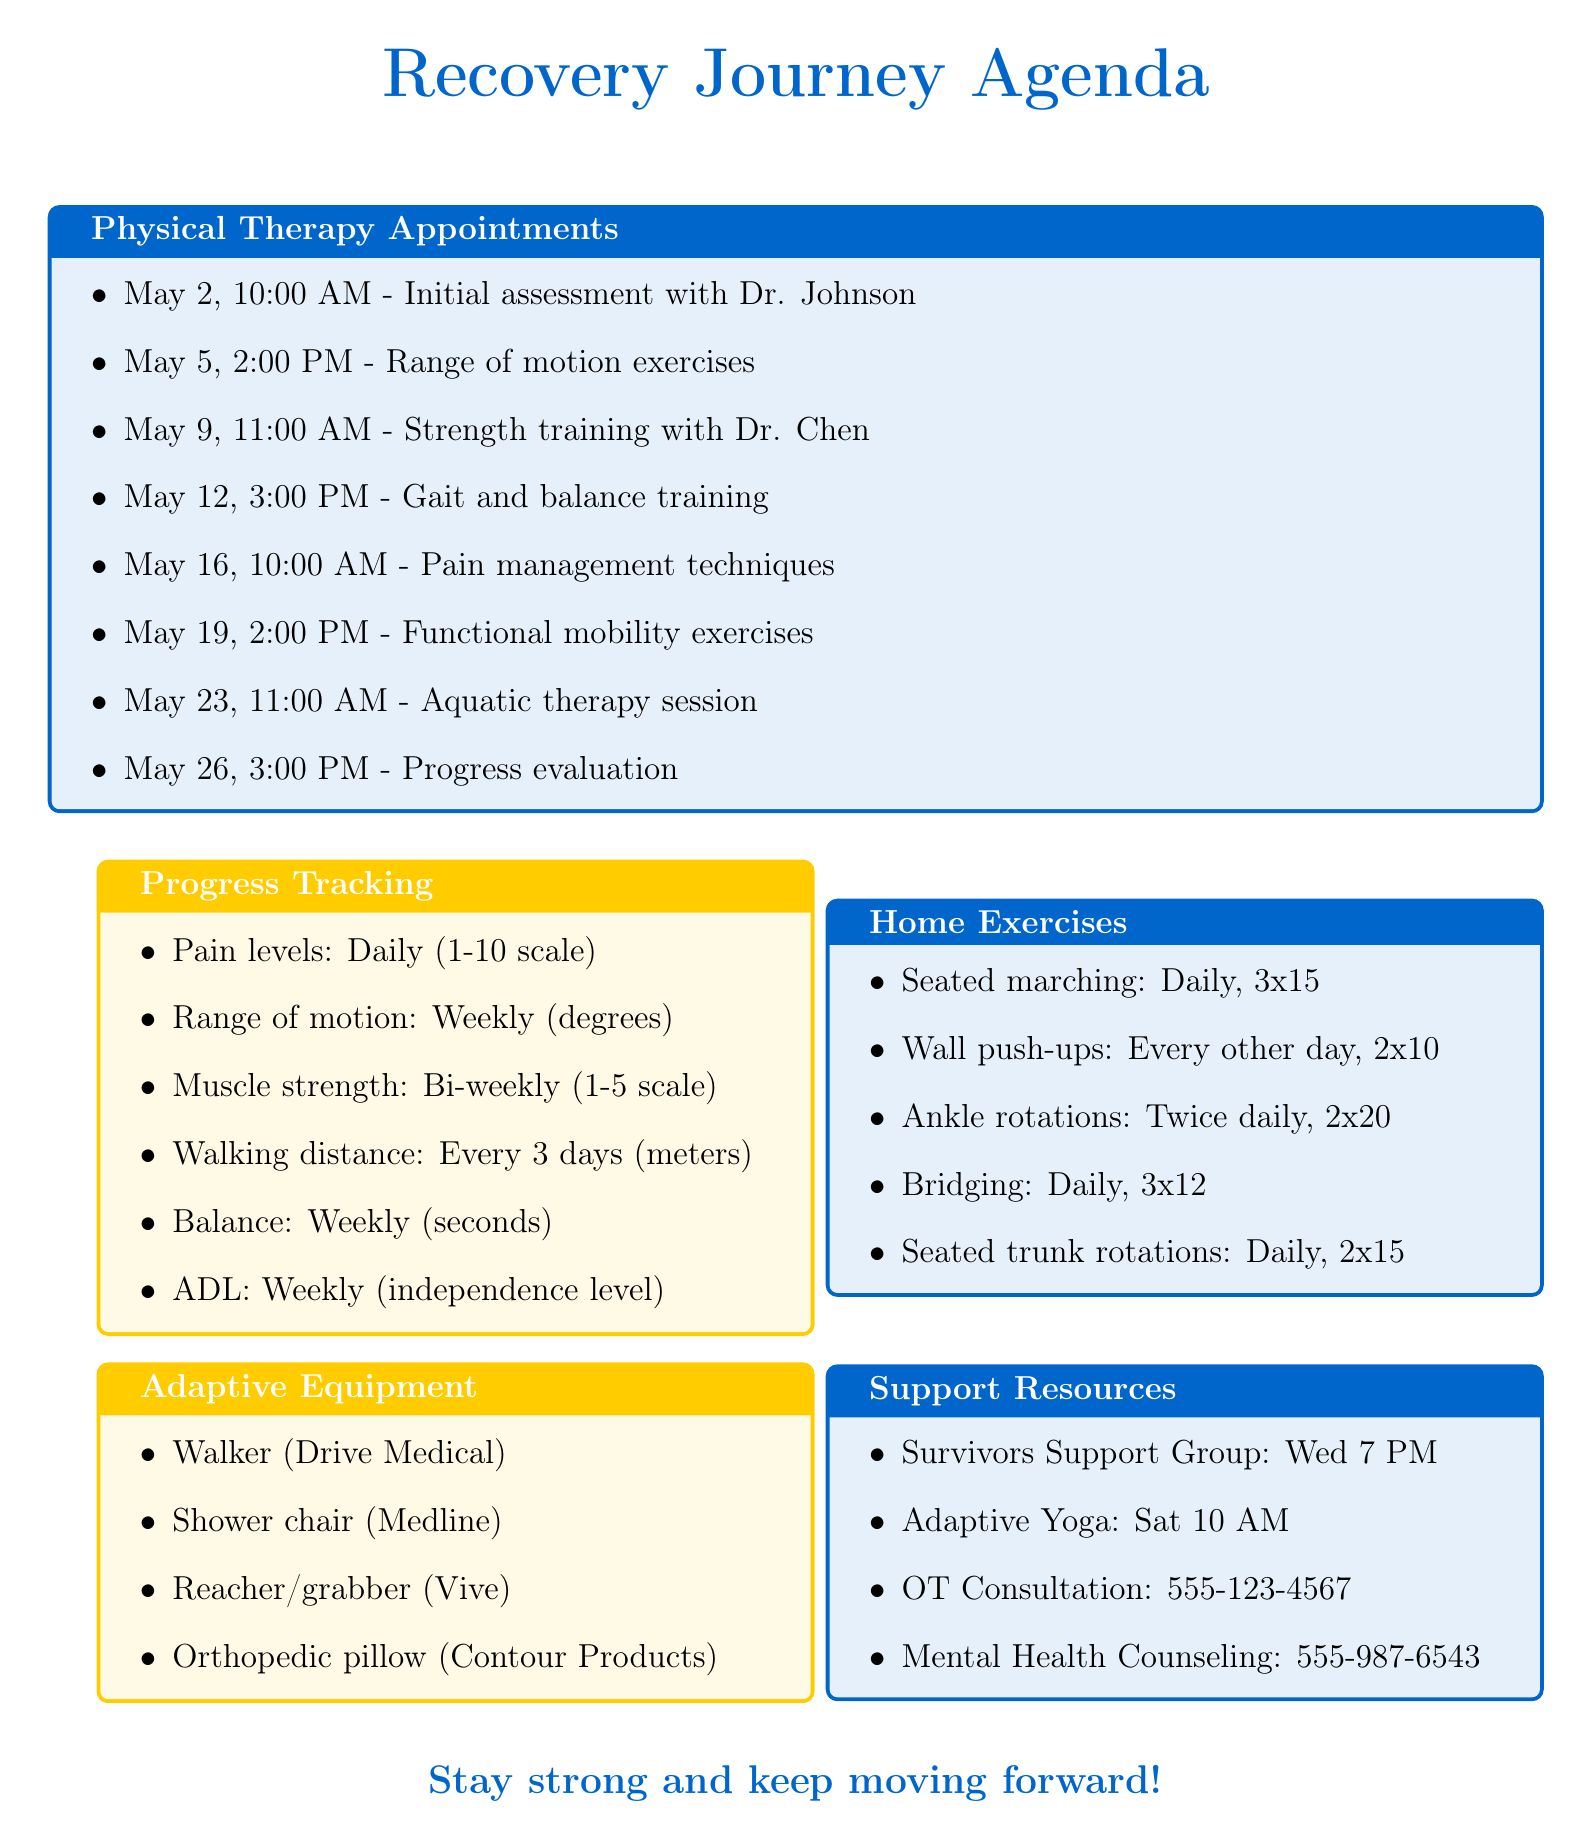What is the date of the first appointment? The first appointment is listed as occurring on May 2, 2023.
Answer: May 2, 2023 Who is the therapist for the aquatic therapy session? The aquatic therapy session is scheduled with Dr. Michael Chen.
Answer: Dr. Michael Chen How often should pain levels be tracked? Pain levels need to be recorded daily according to the progress tracking section.
Answer: Daily What is the focus of the appointment on May 12? The appointment on May 12 focuses on gait training and balance exercises.
Answer: Gait training and balance exercises How many home exercises are listed in the document? There are five home exercises mentioned in the agenda.
Answer: 5 What type of adaptive equipment is used for assisted walking? The document mentions the use of a walker for assisted walking.
Answer: Walker On which day and time does the Adaptive Yoga Class meet? The Yoga Class meets on Saturdays at 10:00 AM as per the support resources.
Answer: Saturdays at 10:00 AM What measurement tool is used for muscle strength tracking? The tracking for muscle strength uses manual muscle testing as the measurement tool.
Answer: Manual muscle testing 